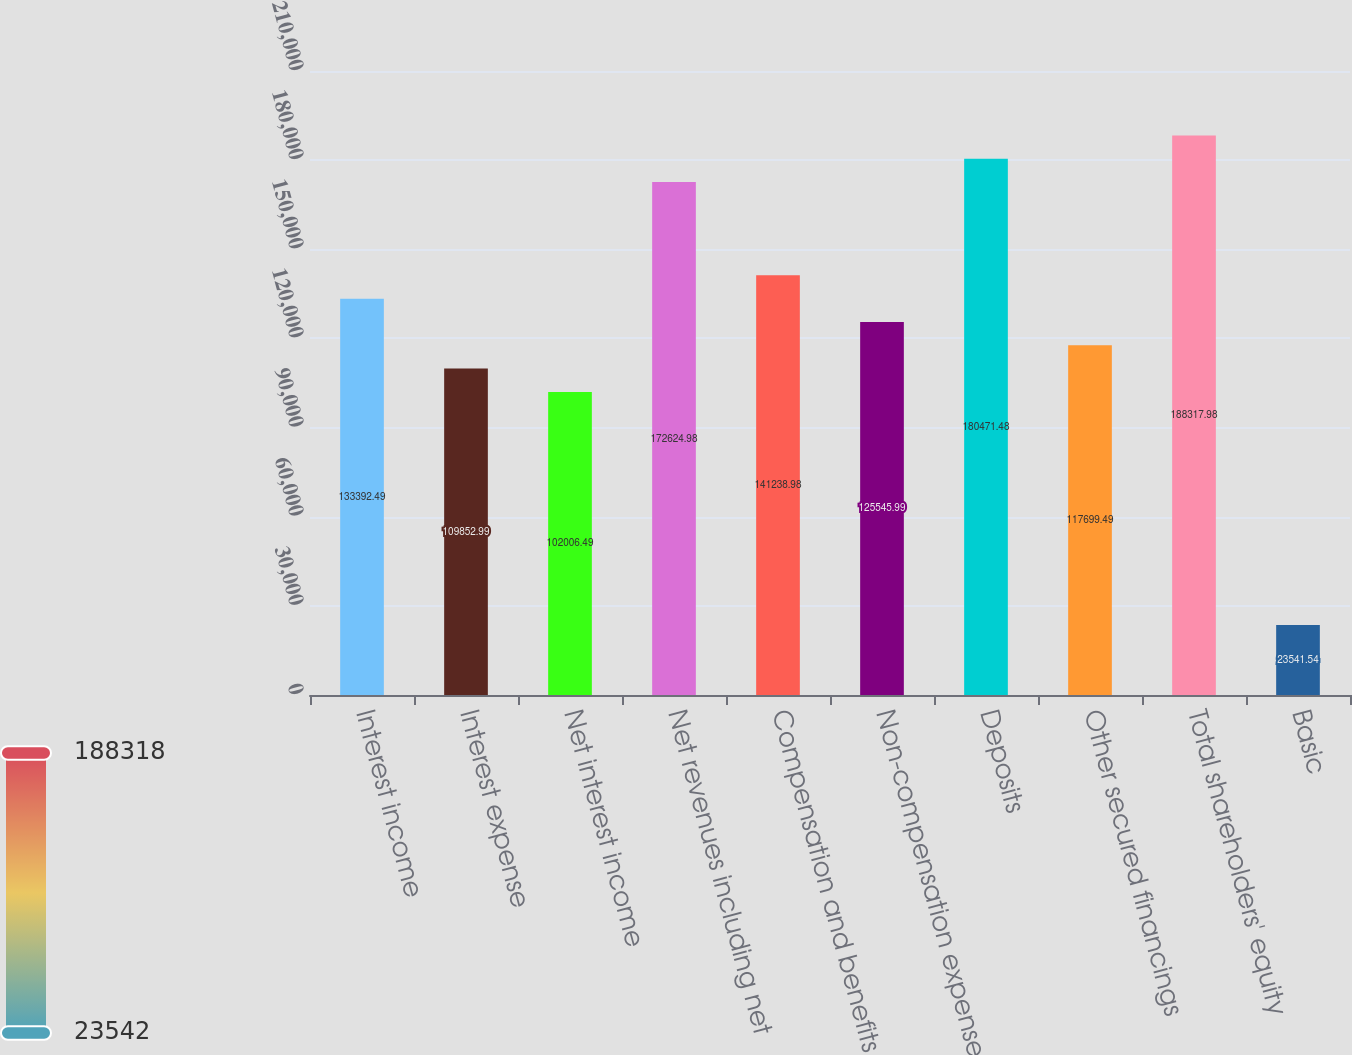Convert chart. <chart><loc_0><loc_0><loc_500><loc_500><bar_chart><fcel>Interest income<fcel>Interest expense<fcel>Net interest income<fcel>Net revenues including net<fcel>Compensation and benefits<fcel>Non-compensation expenses<fcel>Deposits<fcel>Other secured financings<fcel>Total shareholders' equity<fcel>Basic<nl><fcel>133392<fcel>109853<fcel>102006<fcel>172625<fcel>141239<fcel>125546<fcel>180471<fcel>117699<fcel>188318<fcel>23541.5<nl></chart> 